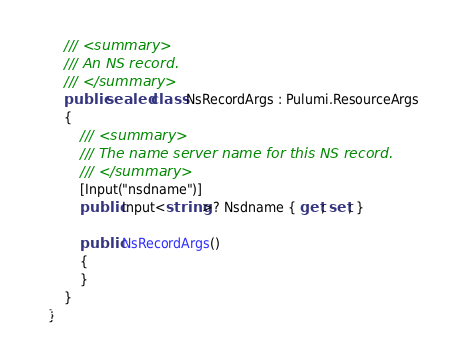<code> <loc_0><loc_0><loc_500><loc_500><_C#_>    /// <summary>
    /// An NS record.
    /// </summary>
    public sealed class NsRecordArgs : Pulumi.ResourceArgs
    {
        /// <summary>
        /// The name server name for this NS record.
        /// </summary>
        [Input("nsdname")]
        public Input<string>? Nsdname { get; set; }

        public NsRecordArgs()
        {
        }
    }
}
</code> 